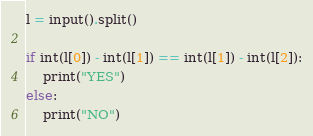<code> <loc_0><loc_0><loc_500><loc_500><_Python_>l = input().split()

if int(l[0]) - int(l[1]) == int(l[1]) - int(l[2]):
    print("YES")
else:
    print("NO")</code> 